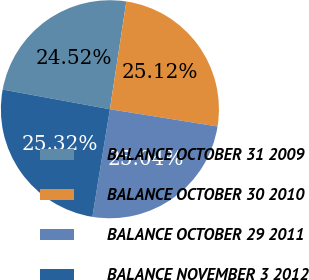Convert chart. <chart><loc_0><loc_0><loc_500><loc_500><pie_chart><fcel>BALANCE OCTOBER 31 2009<fcel>BALANCE OCTOBER 30 2010<fcel>BALANCE OCTOBER 29 2011<fcel>BALANCE NOVEMBER 3 2012<nl><fcel>24.52%<fcel>25.12%<fcel>25.04%<fcel>25.32%<nl></chart> 